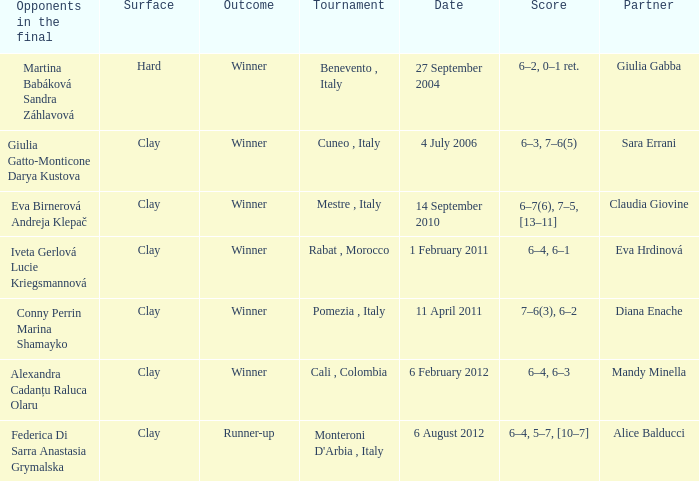Who played on a hard surface? Giulia Gabba. 